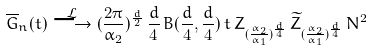<formula> <loc_0><loc_0><loc_500><loc_500>\overline { G } _ { n } ( t ) \overset { \mathcal { L } } { \longrightarrow } ( \frac { 2 \pi } { \alpha _ { 2 } } ) ^ { \frac { d } { 2 } } \, \frac { d } { 4 } \, B ( \frac { d } { 4 } , \frac { d } { 4 } ) \, t \, Z _ { ( \frac { \alpha _ { 2 } } { \alpha _ { 1 } } ) ^ { \frac { d } { 4 } } } \, \widetilde { Z } _ { ( \frac { \alpha _ { 2 } } { \alpha _ { 1 } } ) ^ { \frac { d } { 4 } } } \, N ^ { 2 }</formula> 